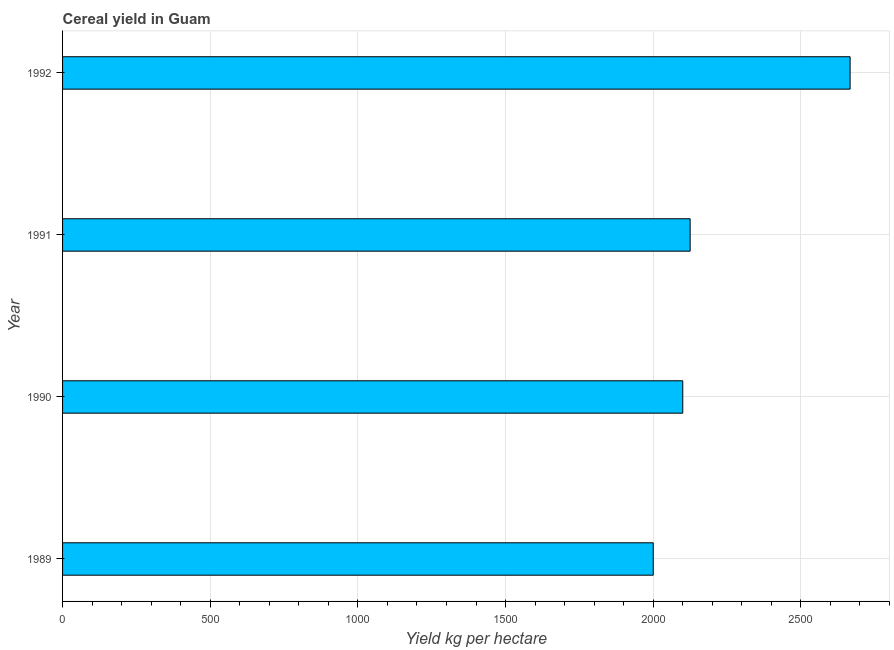Does the graph contain any zero values?
Ensure brevity in your answer.  No. What is the title of the graph?
Your answer should be compact. Cereal yield in Guam. What is the label or title of the X-axis?
Make the answer very short. Yield kg per hectare. What is the cereal yield in 1989?
Your answer should be compact. 2000. Across all years, what is the maximum cereal yield?
Offer a terse response. 2666.67. In which year was the cereal yield minimum?
Offer a terse response. 1989. What is the sum of the cereal yield?
Offer a terse response. 8891.67. What is the difference between the cereal yield in 1991 and 1992?
Your answer should be very brief. -541.67. What is the average cereal yield per year?
Offer a very short reply. 2222.92. What is the median cereal yield?
Provide a succinct answer. 2112.5. In how many years, is the cereal yield greater than 800 kg per hectare?
Your answer should be very brief. 4. Do a majority of the years between 1991 and 1990 (inclusive) have cereal yield greater than 2200 kg per hectare?
Your answer should be compact. No. What is the ratio of the cereal yield in 1991 to that in 1992?
Give a very brief answer. 0.8. Is the difference between the cereal yield in 1989 and 1992 greater than the difference between any two years?
Ensure brevity in your answer.  Yes. What is the difference between the highest and the second highest cereal yield?
Keep it short and to the point. 541.67. Is the sum of the cereal yield in 1990 and 1991 greater than the maximum cereal yield across all years?
Provide a succinct answer. Yes. What is the difference between the highest and the lowest cereal yield?
Keep it short and to the point. 666.67. Are all the bars in the graph horizontal?
Offer a terse response. Yes. What is the Yield kg per hectare in 1989?
Your answer should be very brief. 2000. What is the Yield kg per hectare in 1990?
Provide a short and direct response. 2100. What is the Yield kg per hectare in 1991?
Give a very brief answer. 2125. What is the Yield kg per hectare in 1992?
Give a very brief answer. 2666.67. What is the difference between the Yield kg per hectare in 1989 and 1990?
Your answer should be very brief. -100. What is the difference between the Yield kg per hectare in 1989 and 1991?
Ensure brevity in your answer.  -125. What is the difference between the Yield kg per hectare in 1989 and 1992?
Your answer should be compact. -666.67. What is the difference between the Yield kg per hectare in 1990 and 1991?
Ensure brevity in your answer.  -25. What is the difference between the Yield kg per hectare in 1990 and 1992?
Keep it short and to the point. -566.67. What is the difference between the Yield kg per hectare in 1991 and 1992?
Provide a short and direct response. -541.67. What is the ratio of the Yield kg per hectare in 1989 to that in 1990?
Make the answer very short. 0.95. What is the ratio of the Yield kg per hectare in 1989 to that in 1991?
Offer a very short reply. 0.94. What is the ratio of the Yield kg per hectare in 1989 to that in 1992?
Provide a short and direct response. 0.75. What is the ratio of the Yield kg per hectare in 1990 to that in 1991?
Your answer should be compact. 0.99. What is the ratio of the Yield kg per hectare in 1990 to that in 1992?
Your answer should be compact. 0.79. What is the ratio of the Yield kg per hectare in 1991 to that in 1992?
Provide a succinct answer. 0.8. 